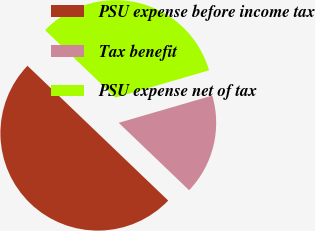Convert chart to OTSL. <chart><loc_0><loc_0><loc_500><loc_500><pie_chart><fcel>PSU expense before income tax<fcel>Tax benefit<fcel>PSU expense net of tax<nl><fcel>50.0%<fcel>16.67%<fcel>33.33%<nl></chart> 